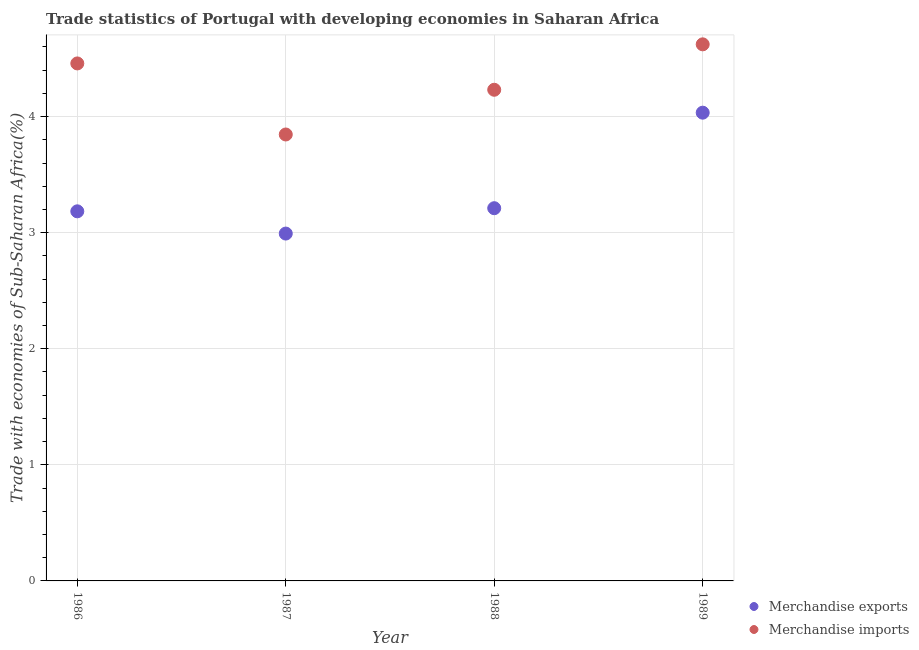How many different coloured dotlines are there?
Your answer should be very brief. 2. Is the number of dotlines equal to the number of legend labels?
Your answer should be compact. Yes. What is the merchandise exports in 1986?
Keep it short and to the point. 3.18. Across all years, what is the maximum merchandise imports?
Keep it short and to the point. 4.62. Across all years, what is the minimum merchandise imports?
Your response must be concise. 3.85. What is the total merchandise imports in the graph?
Your answer should be compact. 17.16. What is the difference between the merchandise exports in 1986 and that in 1987?
Ensure brevity in your answer.  0.19. What is the difference between the merchandise imports in 1987 and the merchandise exports in 1986?
Your answer should be very brief. 0.66. What is the average merchandise imports per year?
Make the answer very short. 4.29. In the year 1987, what is the difference between the merchandise imports and merchandise exports?
Provide a succinct answer. 0.85. What is the ratio of the merchandise imports in 1987 to that in 1988?
Provide a short and direct response. 0.91. Is the merchandise exports in 1988 less than that in 1989?
Your answer should be very brief. Yes. What is the difference between the highest and the second highest merchandise exports?
Ensure brevity in your answer.  0.82. What is the difference between the highest and the lowest merchandise imports?
Offer a terse response. 0.78. Is the sum of the merchandise imports in 1987 and 1988 greater than the maximum merchandise exports across all years?
Your answer should be compact. Yes. Is the merchandise exports strictly less than the merchandise imports over the years?
Offer a terse response. Yes. How many years are there in the graph?
Your answer should be compact. 4. Does the graph contain grids?
Give a very brief answer. Yes. Where does the legend appear in the graph?
Your answer should be very brief. Bottom right. How are the legend labels stacked?
Provide a short and direct response. Vertical. What is the title of the graph?
Ensure brevity in your answer.  Trade statistics of Portugal with developing economies in Saharan Africa. Does "Netherlands" appear as one of the legend labels in the graph?
Keep it short and to the point. No. What is the label or title of the Y-axis?
Ensure brevity in your answer.  Trade with economies of Sub-Saharan Africa(%). What is the Trade with economies of Sub-Saharan Africa(%) of Merchandise exports in 1986?
Offer a terse response. 3.18. What is the Trade with economies of Sub-Saharan Africa(%) of Merchandise imports in 1986?
Make the answer very short. 4.46. What is the Trade with economies of Sub-Saharan Africa(%) in Merchandise exports in 1987?
Ensure brevity in your answer.  2.99. What is the Trade with economies of Sub-Saharan Africa(%) in Merchandise imports in 1987?
Your answer should be very brief. 3.85. What is the Trade with economies of Sub-Saharan Africa(%) in Merchandise exports in 1988?
Provide a succinct answer. 3.21. What is the Trade with economies of Sub-Saharan Africa(%) in Merchandise imports in 1988?
Provide a succinct answer. 4.23. What is the Trade with economies of Sub-Saharan Africa(%) in Merchandise exports in 1989?
Ensure brevity in your answer.  4.03. What is the Trade with economies of Sub-Saharan Africa(%) of Merchandise imports in 1989?
Give a very brief answer. 4.62. Across all years, what is the maximum Trade with economies of Sub-Saharan Africa(%) of Merchandise exports?
Give a very brief answer. 4.03. Across all years, what is the maximum Trade with economies of Sub-Saharan Africa(%) in Merchandise imports?
Give a very brief answer. 4.62. Across all years, what is the minimum Trade with economies of Sub-Saharan Africa(%) in Merchandise exports?
Your response must be concise. 2.99. Across all years, what is the minimum Trade with economies of Sub-Saharan Africa(%) of Merchandise imports?
Keep it short and to the point. 3.85. What is the total Trade with economies of Sub-Saharan Africa(%) of Merchandise exports in the graph?
Your answer should be very brief. 13.42. What is the total Trade with economies of Sub-Saharan Africa(%) of Merchandise imports in the graph?
Provide a succinct answer. 17.16. What is the difference between the Trade with economies of Sub-Saharan Africa(%) in Merchandise exports in 1986 and that in 1987?
Ensure brevity in your answer.  0.19. What is the difference between the Trade with economies of Sub-Saharan Africa(%) of Merchandise imports in 1986 and that in 1987?
Make the answer very short. 0.61. What is the difference between the Trade with economies of Sub-Saharan Africa(%) in Merchandise exports in 1986 and that in 1988?
Give a very brief answer. -0.03. What is the difference between the Trade with economies of Sub-Saharan Africa(%) of Merchandise imports in 1986 and that in 1988?
Keep it short and to the point. 0.23. What is the difference between the Trade with economies of Sub-Saharan Africa(%) of Merchandise exports in 1986 and that in 1989?
Make the answer very short. -0.85. What is the difference between the Trade with economies of Sub-Saharan Africa(%) in Merchandise imports in 1986 and that in 1989?
Make the answer very short. -0.16. What is the difference between the Trade with economies of Sub-Saharan Africa(%) in Merchandise exports in 1987 and that in 1988?
Your answer should be compact. -0.22. What is the difference between the Trade with economies of Sub-Saharan Africa(%) in Merchandise imports in 1987 and that in 1988?
Give a very brief answer. -0.39. What is the difference between the Trade with economies of Sub-Saharan Africa(%) of Merchandise exports in 1987 and that in 1989?
Provide a succinct answer. -1.04. What is the difference between the Trade with economies of Sub-Saharan Africa(%) of Merchandise imports in 1987 and that in 1989?
Offer a terse response. -0.78. What is the difference between the Trade with economies of Sub-Saharan Africa(%) of Merchandise exports in 1988 and that in 1989?
Provide a short and direct response. -0.82. What is the difference between the Trade with economies of Sub-Saharan Africa(%) in Merchandise imports in 1988 and that in 1989?
Your answer should be compact. -0.39. What is the difference between the Trade with economies of Sub-Saharan Africa(%) in Merchandise exports in 1986 and the Trade with economies of Sub-Saharan Africa(%) in Merchandise imports in 1987?
Make the answer very short. -0.66. What is the difference between the Trade with economies of Sub-Saharan Africa(%) in Merchandise exports in 1986 and the Trade with economies of Sub-Saharan Africa(%) in Merchandise imports in 1988?
Offer a terse response. -1.05. What is the difference between the Trade with economies of Sub-Saharan Africa(%) of Merchandise exports in 1986 and the Trade with economies of Sub-Saharan Africa(%) of Merchandise imports in 1989?
Keep it short and to the point. -1.44. What is the difference between the Trade with economies of Sub-Saharan Africa(%) in Merchandise exports in 1987 and the Trade with economies of Sub-Saharan Africa(%) in Merchandise imports in 1988?
Offer a terse response. -1.24. What is the difference between the Trade with economies of Sub-Saharan Africa(%) of Merchandise exports in 1987 and the Trade with economies of Sub-Saharan Africa(%) of Merchandise imports in 1989?
Your answer should be compact. -1.63. What is the difference between the Trade with economies of Sub-Saharan Africa(%) in Merchandise exports in 1988 and the Trade with economies of Sub-Saharan Africa(%) in Merchandise imports in 1989?
Your response must be concise. -1.41. What is the average Trade with economies of Sub-Saharan Africa(%) in Merchandise exports per year?
Keep it short and to the point. 3.36. What is the average Trade with economies of Sub-Saharan Africa(%) of Merchandise imports per year?
Provide a short and direct response. 4.29. In the year 1986, what is the difference between the Trade with economies of Sub-Saharan Africa(%) in Merchandise exports and Trade with economies of Sub-Saharan Africa(%) in Merchandise imports?
Ensure brevity in your answer.  -1.27. In the year 1987, what is the difference between the Trade with economies of Sub-Saharan Africa(%) in Merchandise exports and Trade with economies of Sub-Saharan Africa(%) in Merchandise imports?
Provide a short and direct response. -0.85. In the year 1988, what is the difference between the Trade with economies of Sub-Saharan Africa(%) in Merchandise exports and Trade with economies of Sub-Saharan Africa(%) in Merchandise imports?
Your answer should be compact. -1.02. In the year 1989, what is the difference between the Trade with economies of Sub-Saharan Africa(%) in Merchandise exports and Trade with economies of Sub-Saharan Africa(%) in Merchandise imports?
Your answer should be very brief. -0.59. What is the ratio of the Trade with economies of Sub-Saharan Africa(%) in Merchandise exports in 1986 to that in 1987?
Your answer should be compact. 1.06. What is the ratio of the Trade with economies of Sub-Saharan Africa(%) of Merchandise imports in 1986 to that in 1987?
Provide a succinct answer. 1.16. What is the ratio of the Trade with economies of Sub-Saharan Africa(%) of Merchandise imports in 1986 to that in 1988?
Make the answer very short. 1.05. What is the ratio of the Trade with economies of Sub-Saharan Africa(%) of Merchandise exports in 1986 to that in 1989?
Your answer should be very brief. 0.79. What is the ratio of the Trade with economies of Sub-Saharan Africa(%) in Merchandise imports in 1986 to that in 1989?
Your answer should be very brief. 0.96. What is the ratio of the Trade with economies of Sub-Saharan Africa(%) of Merchandise exports in 1987 to that in 1988?
Ensure brevity in your answer.  0.93. What is the ratio of the Trade with economies of Sub-Saharan Africa(%) in Merchandise imports in 1987 to that in 1988?
Ensure brevity in your answer.  0.91. What is the ratio of the Trade with economies of Sub-Saharan Africa(%) of Merchandise exports in 1987 to that in 1989?
Ensure brevity in your answer.  0.74. What is the ratio of the Trade with economies of Sub-Saharan Africa(%) of Merchandise imports in 1987 to that in 1989?
Your answer should be very brief. 0.83. What is the ratio of the Trade with economies of Sub-Saharan Africa(%) of Merchandise exports in 1988 to that in 1989?
Offer a terse response. 0.8. What is the ratio of the Trade with economies of Sub-Saharan Africa(%) of Merchandise imports in 1988 to that in 1989?
Your answer should be compact. 0.92. What is the difference between the highest and the second highest Trade with economies of Sub-Saharan Africa(%) in Merchandise exports?
Make the answer very short. 0.82. What is the difference between the highest and the second highest Trade with economies of Sub-Saharan Africa(%) in Merchandise imports?
Your answer should be very brief. 0.16. What is the difference between the highest and the lowest Trade with economies of Sub-Saharan Africa(%) in Merchandise exports?
Offer a very short reply. 1.04. What is the difference between the highest and the lowest Trade with economies of Sub-Saharan Africa(%) in Merchandise imports?
Ensure brevity in your answer.  0.78. 